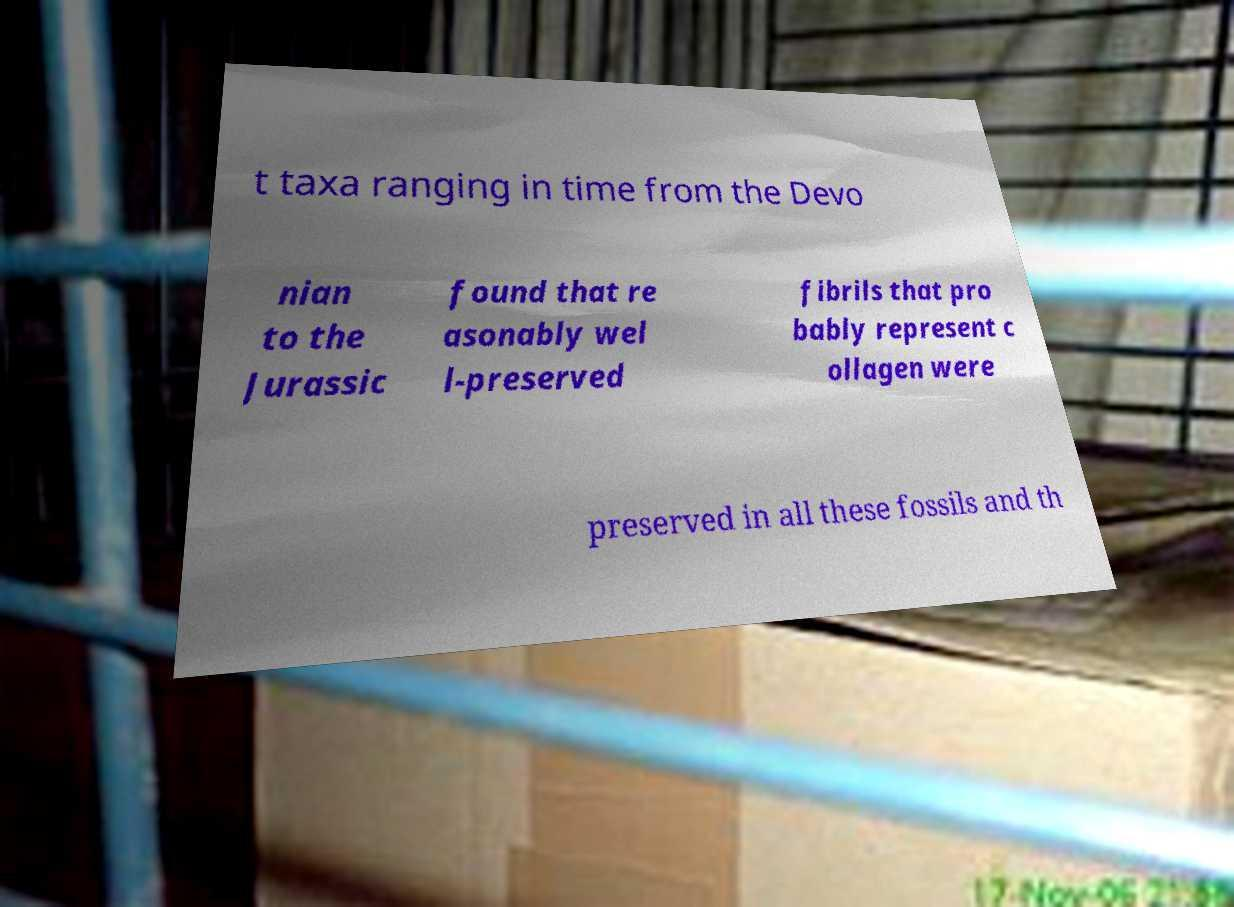Please read and relay the text visible in this image. What does it say? t taxa ranging in time from the Devo nian to the Jurassic found that re asonably wel l-preserved fibrils that pro bably represent c ollagen were preserved in all these fossils and th 